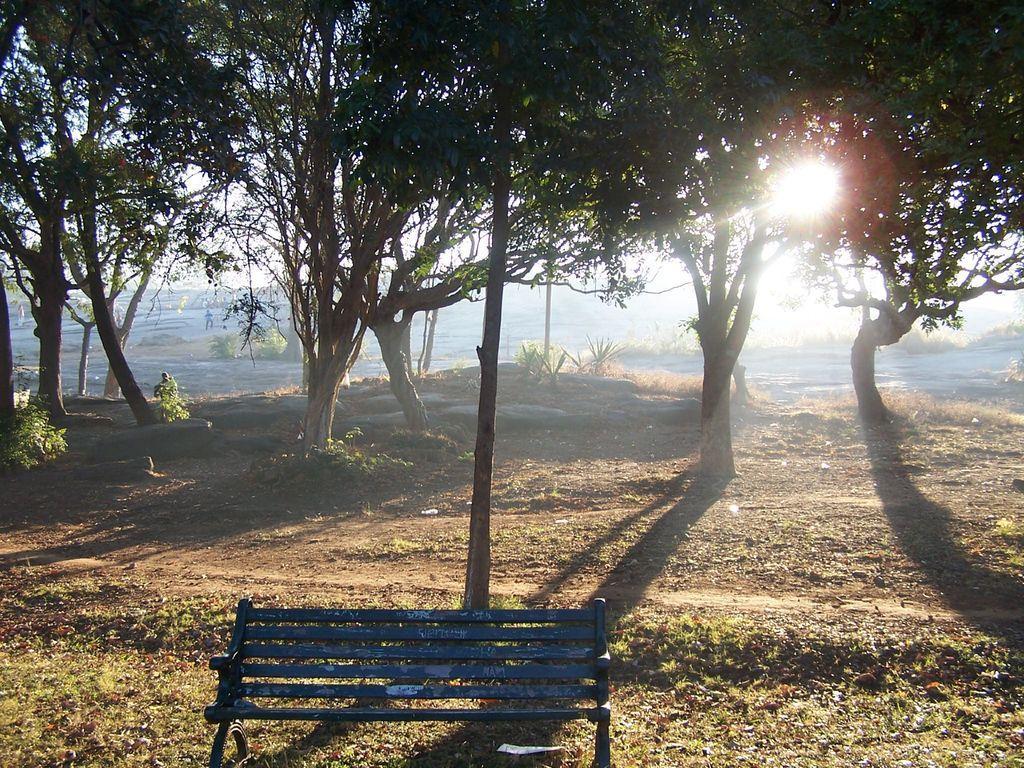How would you summarize this image in a sentence or two? In this picture we can see many trees. On the bottom we can see bench near to the pole. In the background there is a water. Here we can see sun. Here we can see sky. 